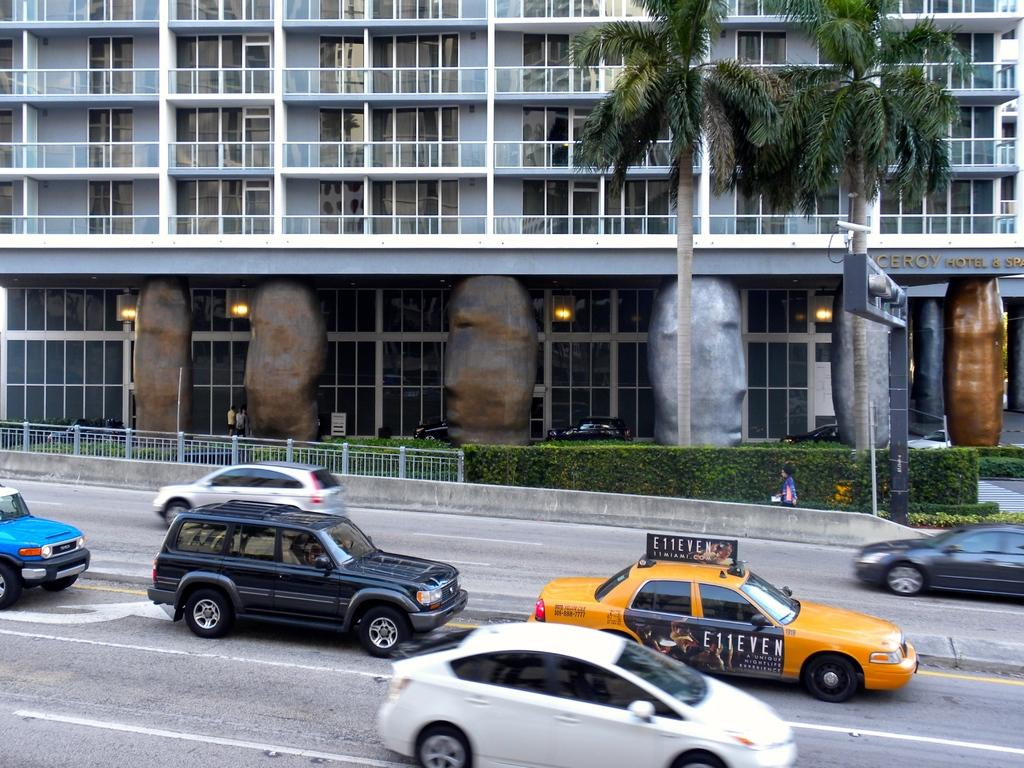What is the main feature of the image? There is a road in the image. What can be seen on the road? There are cars on the road. What is visible in the background of the image? There is a building, plants, and trees in the background of the image. What is a specific detail about the building? There are windows in the building. What architectural feature can be seen in the image? There is a railing in the image. What type of cake is being served at the insurance company in the image? There is no cake or insurance company present in the image. What is the tin used for in the image? There is no tin present in the image. 